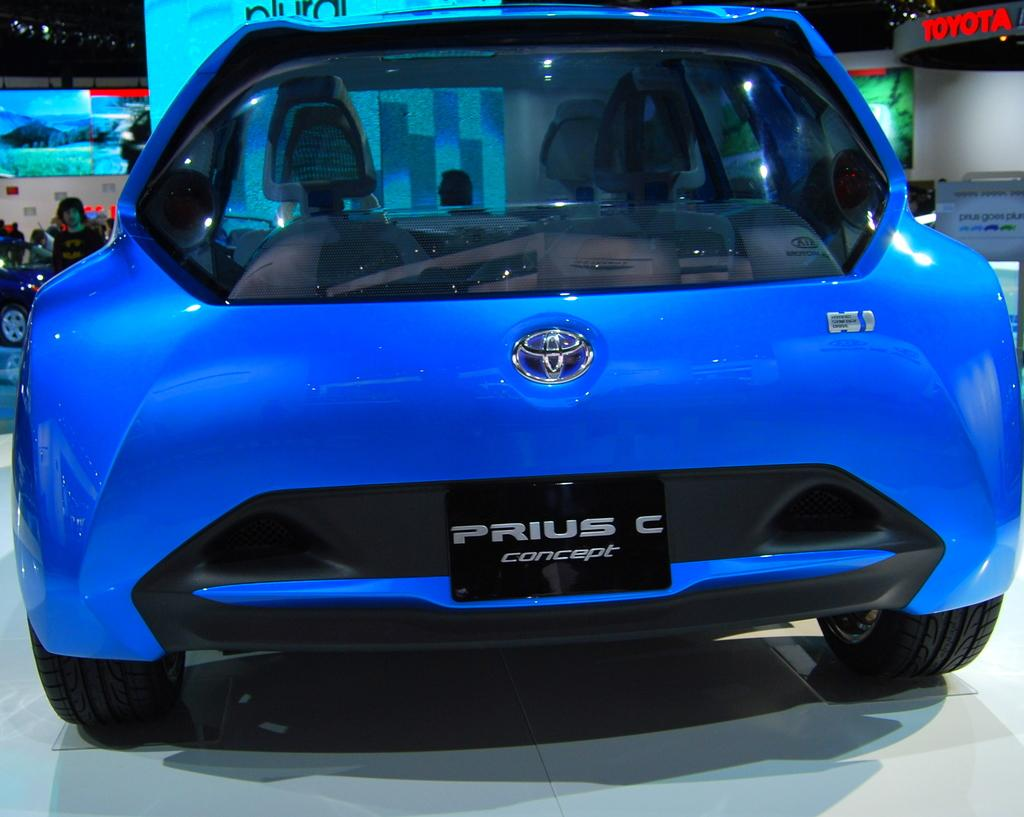What type of vehicle is in the foreground of the image? There is a blue car in the foreground of the image. What else can be seen in the image besides the blue car? There is a group of people at the back of the image, hoardings are visible, and there is another car in the image. What type of ornament is hanging from the rearview mirror of the blue car? There is no information about any ornament hanging from the rearview mirror of the blue car in the image. 